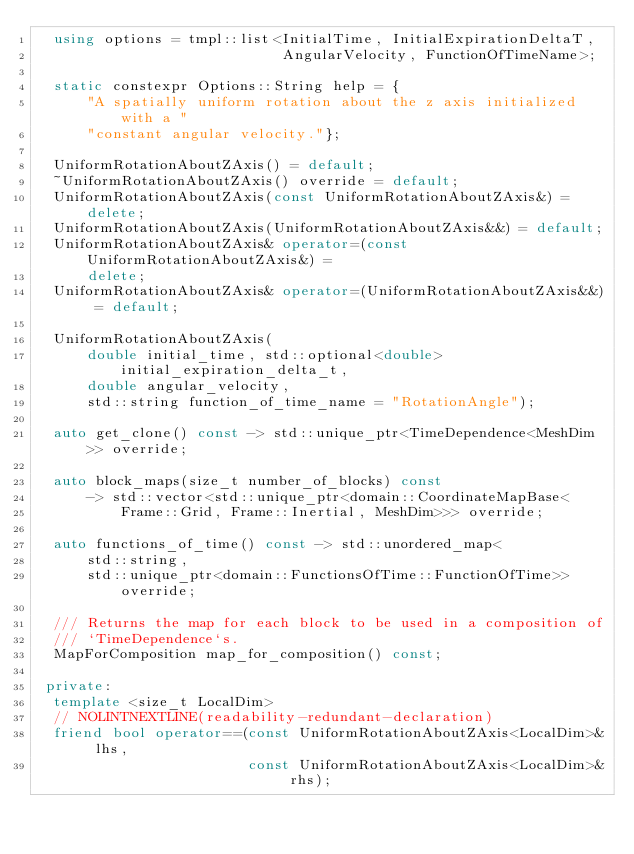Convert code to text. <code><loc_0><loc_0><loc_500><loc_500><_C++_>  using options = tmpl::list<InitialTime, InitialExpirationDeltaT,
                             AngularVelocity, FunctionOfTimeName>;

  static constexpr Options::String help = {
      "A spatially uniform rotation about the z axis initialized with a "
      "constant angular velocity."};

  UniformRotationAboutZAxis() = default;
  ~UniformRotationAboutZAxis() override = default;
  UniformRotationAboutZAxis(const UniformRotationAboutZAxis&) = delete;
  UniformRotationAboutZAxis(UniformRotationAboutZAxis&&) = default;
  UniformRotationAboutZAxis& operator=(const UniformRotationAboutZAxis&) =
      delete;
  UniformRotationAboutZAxis& operator=(UniformRotationAboutZAxis&&) = default;

  UniformRotationAboutZAxis(
      double initial_time, std::optional<double> initial_expiration_delta_t,
      double angular_velocity,
      std::string function_of_time_name = "RotationAngle");

  auto get_clone() const -> std::unique_ptr<TimeDependence<MeshDim>> override;

  auto block_maps(size_t number_of_blocks) const
      -> std::vector<std::unique_ptr<domain::CoordinateMapBase<
          Frame::Grid, Frame::Inertial, MeshDim>>> override;

  auto functions_of_time() const -> std::unordered_map<
      std::string,
      std::unique_ptr<domain::FunctionsOfTime::FunctionOfTime>> override;

  /// Returns the map for each block to be used in a composition of
  /// `TimeDependence`s.
  MapForComposition map_for_composition() const;

 private:
  template <size_t LocalDim>
  // NOLINTNEXTLINE(readability-redundant-declaration)
  friend bool operator==(const UniformRotationAboutZAxis<LocalDim>& lhs,
                         const UniformRotationAboutZAxis<LocalDim>& rhs);
</code> 